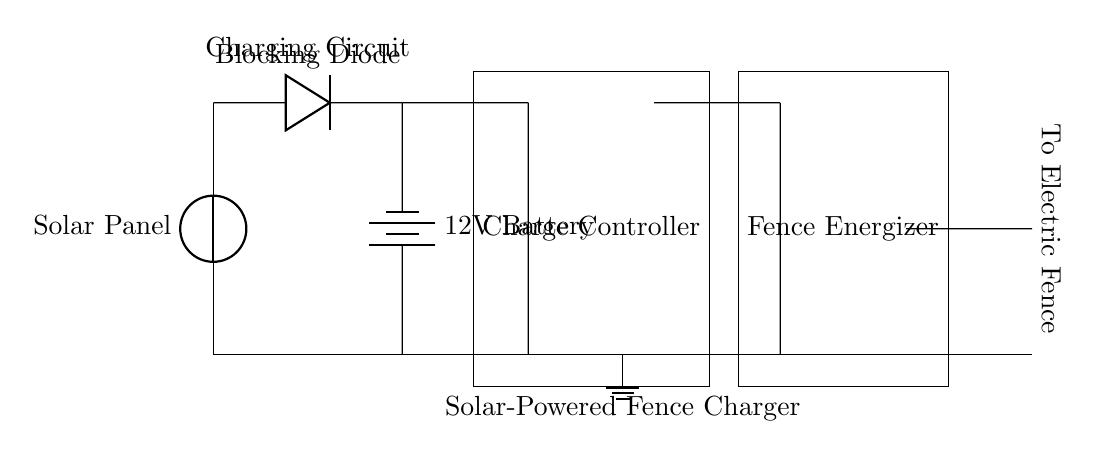What is the main power source for this circuit? The main power source is the solar panel, which is represented as a voltage source at the top of the diagram. It collects solar energy and converts it into electrical power.
Answer: Solar Panel What component is used to prevent current from flowing back into the solar panel? The blocking diode is utilized for this purpose, positioned between the solar panel and the battery. Diodes allow current to flow in one direction only, protecting the solar panel from reverse current.
Answer: Blocking Diode What is the voltage rating of the battery in the circuit? The battery is labeled as a 12V battery, which indicates the voltage it supplies to the circuit. This information is directly stated next to the battery symbol in the diagram.
Answer: 12V Battery Which component is responsible for regulating the charge to the battery? The charge controller is the component that manages the charging process of the battery, ensuring it does not overcharge. It is depicted as a rectangle in the center of the circuit diagram.
Answer: Charge Controller How does the electric fence receive power in this circuit? The electric fence receives power through the fence energizer, which is connected to the output from the charge controller. This energizer converts the stored energy in the battery into a high-voltage pulse to energize the fence.
Answer: Through Fence Energizer Is the ground connection made in the circuit? Yes, there is a ground connection shown at the bottom of the diagram, which is important for safety and stability in electrical circuits. The ground helps to define a reference point for the voltage levels in the circuit.
Answer: Yes What is the purpose of the circuit as a whole? The main purpose of the circuit is to provide reliable power to an electric fence using solar energy, ensuring that the fence is properly energized without needing conventional electricity sources.
Answer: Solar-Powered Fence Charger 